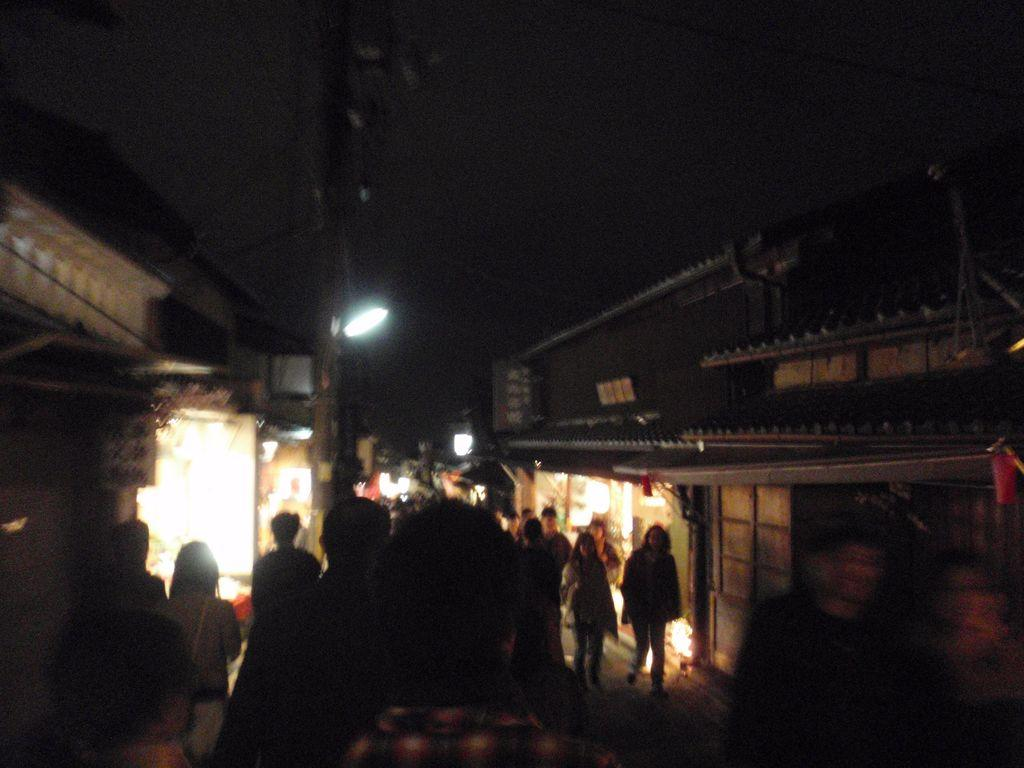What is happening with the group of people in the image? The group of people is on the ground in the image. What can be seen in the background of the image? Buildings are visible in the image. What is illuminating the scene in the image? Lights are present in the image. What structures are supporting the lights? Poles are visible in the image. What else can be seen in the image besides the people and lights? There are some objects in the image. How would you describe the overall lighting in the image? The background of the image is dark. What type of shoe is the achiever wearing in the image? There is no achiever or shoe present in the image. What trick is being performed by the people in the image? There is no trick being performed by the people in the image; they are simply on the ground. 